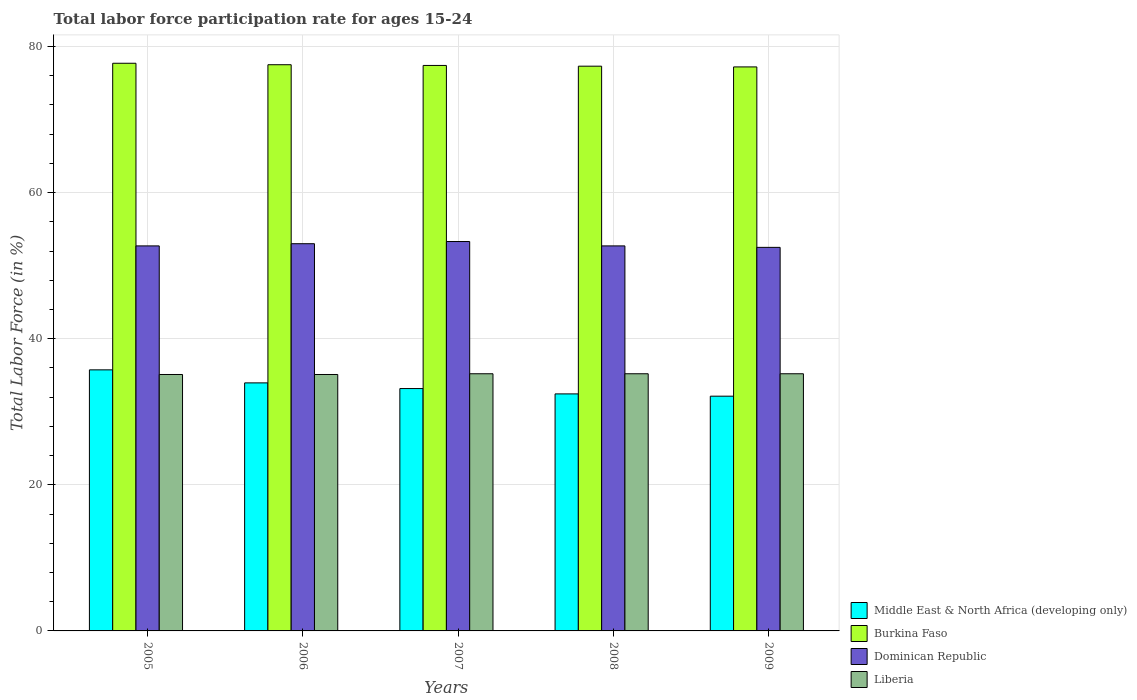How many groups of bars are there?
Offer a terse response. 5. Are the number of bars on each tick of the X-axis equal?
Provide a succinct answer. Yes. In how many cases, is the number of bars for a given year not equal to the number of legend labels?
Offer a very short reply. 0. What is the labor force participation rate in Middle East & North Africa (developing only) in 2007?
Provide a succinct answer. 33.18. Across all years, what is the maximum labor force participation rate in Middle East & North Africa (developing only)?
Your answer should be compact. 35.73. Across all years, what is the minimum labor force participation rate in Middle East & North Africa (developing only)?
Provide a short and direct response. 32.13. What is the total labor force participation rate in Middle East & North Africa (developing only) in the graph?
Offer a very short reply. 167.43. What is the difference between the labor force participation rate in Dominican Republic in 2005 and that in 2007?
Give a very brief answer. -0.6. What is the difference between the labor force participation rate in Middle East & North Africa (developing only) in 2008 and the labor force participation rate in Dominican Republic in 2009?
Offer a terse response. -20.06. What is the average labor force participation rate in Middle East & North Africa (developing only) per year?
Your answer should be compact. 33.49. In the year 2009, what is the difference between the labor force participation rate in Liberia and labor force participation rate in Burkina Faso?
Give a very brief answer. -42. What is the ratio of the labor force participation rate in Dominican Republic in 2006 to that in 2009?
Offer a terse response. 1.01. What is the difference between the highest and the second highest labor force participation rate in Burkina Faso?
Provide a succinct answer. 0.2. What is the difference between the highest and the lowest labor force participation rate in Middle East & North Africa (developing only)?
Your answer should be very brief. 3.6. In how many years, is the labor force participation rate in Burkina Faso greater than the average labor force participation rate in Burkina Faso taken over all years?
Keep it short and to the point. 2. Is the sum of the labor force participation rate in Burkina Faso in 2006 and 2007 greater than the maximum labor force participation rate in Liberia across all years?
Make the answer very short. Yes. Is it the case that in every year, the sum of the labor force participation rate in Dominican Republic and labor force participation rate in Middle East & North Africa (developing only) is greater than the sum of labor force participation rate in Burkina Faso and labor force participation rate in Liberia?
Make the answer very short. No. What does the 4th bar from the left in 2009 represents?
Ensure brevity in your answer.  Liberia. What does the 3rd bar from the right in 2007 represents?
Keep it short and to the point. Burkina Faso. Is it the case that in every year, the sum of the labor force participation rate in Dominican Republic and labor force participation rate in Liberia is greater than the labor force participation rate in Burkina Faso?
Offer a very short reply. Yes. How many bars are there?
Your response must be concise. 20. Are all the bars in the graph horizontal?
Offer a terse response. No. How many years are there in the graph?
Your answer should be very brief. 5. Does the graph contain any zero values?
Your response must be concise. No. How many legend labels are there?
Give a very brief answer. 4. What is the title of the graph?
Ensure brevity in your answer.  Total labor force participation rate for ages 15-24. Does "Gambia, The" appear as one of the legend labels in the graph?
Ensure brevity in your answer.  No. What is the label or title of the X-axis?
Provide a short and direct response. Years. What is the Total Labor Force (in %) of Middle East & North Africa (developing only) in 2005?
Offer a very short reply. 35.73. What is the Total Labor Force (in %) of Burkina Faso in 2005?
Offer a very short reply. 77.7. What is the Total Labor Force (in %) of Dominican Republic in 2005?
Offer a very short reply. 52.7. What is the Total Labor Force (in %) of Liberia in 2005?
Provide a short and direct response. 35.1. What is the Total Labor Force (in %) in Middle East & North Africa (developing only) in 2006?
Make the answer very short. 33.95. What is the Total Labor Force (in %) of Burkina Faso in 2006?
Provide a succinct answer. 77.5. What is the Total Labor Force (in %) in Liberia in 2006?
Keep it short and to the point. 35.1. What is the Total Labor Force (in %) of Middle East & North Africa (developing only) in 2007?
Ensure brevity in your answer.  33.18. What is the Total Labor Force (in %) of Burkina Faso in 2007?
Make the answer very short. 77.4. What is the Total Labor Force (in %) of Dominican Republic in 2007?
Give a very brief answer. 53.3. What is the Total Labor Force (in %) in Liberia in 2007?
Give a very brief answer. 35.2. What is the Total Labor Force (in %) in Middle East & North Africa (developing only) in 2008?
Give a very brief answer. 32.44. What is the Total Labor Force (in %) in Burkina Faso in 2008?
Provide a succinct answer. 77.3. What is the Total Labor Force (in %) of Dominican Republic in 2008?
Provide a succinct answer. 52.7. What is the Total Labor Force (in %) in Liberia in 2008?
Provide a short and direct response. 35.2. What is the Total Labor Force (in %) of Middle East & North Africa (developing only) in 2009?
Provide a succinct answer. 32.13. What is the Total Labor Force (in %) of Burkina Faso in 2009?
Keep it short and to the point. 77.2. What is the Total Labor Force (in %) in Dominican Republic in 2009?
Your answer should be compact. 52.5. What is the Total Labor Force (in %) of Liberia in 2009?
Provide a short and direct response. 35.2. Across all years, what is the maximum Total Labor Force (in %) of Middle East & North Africa (developing only)?
Ensure brevity in your answer.  35.73. Across all years, what is the maximum Total Labor Force (in %) in Burkina Faso?
Keep it short and to the point. 77.7. Across all years, what is the maximum Total Labor Force (in %) in Dominican Republic?
Offer a very short reply. 53.3. Across all years, what is the maximum Total Labor Force (in %) of Liberia?
Give a very brief answer. 35.2. Across all years, what is the minimum Total Labor Force (in %) in Middle East & North Africa (developing only)?
Ensure brevity in your answer.  32.13. Across all years, what is the minimum Total Labor Force (in %) of Burkina Faso?
Offer a terse response. 77.2. Across all years, what is the minimum Total Labor Force (in %) in Dominican Republic?
Your answer should be compact. 52.5. Across all years, what is the minimum Total Labor Force (in %) in Liberia?
Make the answer very short. 35.1. What is the total Total Labor Force (in %) of Middle East & North Africa (developing only) in the graph?
Keep it short and to the point. 167.43. What is the total Total Labor Force (in %) in Burkina Faso in the graph?
Your response must be concise. 387.1. What is the total Total Labor Force (in %) of Dominican Republic in the graph?
Your response must be concise. 264.2. What is the total Total Labor Force (in %) in Liberia in the graph?
Offer a very short reply. 175.8. What is the difference between the Total Labor Force (in %) of Middle East & North Africa (developing only) in 2005 and that in 2006?
Your answer should be very brief. 1.78. What is the difference between the Total Labor Force (in %) in Dominican Republic in 2005 and that in 2006?
Provide a succinct answer. -0.3. What is the difference between the Total Labor Force (in %) of Middle East & North Africa (developing only) in 2005 and that in 2007?
Keep it short and to the point. 2.56. What is the difference between the Total Labor Force (in %) of Middle East & North Africa (developing only) in 2005 and that in 2008?
Your answer should be very brief. 3.29. What is the difference between the Total Labor Force (in %) in Dominican Republic in 2005 and that in 2008?
Your response must be concise. 0. What is the difference between the Total Labor Force (in %) of Liberia in 2005 and that in 2008?
Your answer should be compact. -0.1. What is the difference between the Total Labor Force (in %) of Middle East & North Africa (developing only) in 2005 and that in 2009?
Make the answer very short. 3.6. What is the difference between the Total Labor Force (in %) in Middle East & North Africa (developing only) in 2006 and that in 2007?
Give a very brief answer. 0.78. What is the difference between the Total Labor Force (in %) in Burkina Faso in 2006 and that in 2007?
Your response must be concise. 0.1. What is the difference between the Total Labor Force (in %) of Middle East & North Africa (developing only) in 2006 and that in 2008?
Make the answer very short. 1.51. What is the difference between the Total Labor Force (in %) in Burkina Faso in 2006 and that in 2008?
Provide a succinct answer. 0.2. What is the difference between the Total Labor Force (in %) in Dominican Republic in 2006 and that in 2008?
Provide a succinct answer. 0.3. What is the difference between the Total Labor Force (in %) of Liberia in 2006 and that in 2008?
Ensure brevity in your answer.  -0.1. What is the difference between the Total Labor Force (in %) in Middle East & North Africa (developing only) in 2006 and that in 2009?
Give a very brief answer. 1.82. What is the difference between the Total Labor Force (in %) in Burkina Faso in 2006 and that in 2009?
Provide a short and direct response. 0.3. What is the difference between the Total Labor Force (in %) of Dominican Republic in 2006 and that in 2009?
Make the answer very short. 0.5. What is the difference between the Total Labor Force (in %) of Middle East & North Africa (developing only) in 2007 and that in 2008?
Ensure brevity in your answer.  0.73. What is the difference between the Total Labor Force (in %) of Dominican Republic in 2007 and that in 2008?
Provide a succinct answer. 0.6. What is the difference between the Total Labor Force (in %) in Middle East & North Africa (developing only) in 2007 and that in 2009?
Offer a very short reply. 1.04. What is the difference between the Total Labor Force (in %) of Burkina Faso in 2007 and that in 2009?
Give a very brief answer. 0.2. What is the difference between the Total Labor Force (in %) in Dominican Republic in 2007 and that in 2009?
Give a very brief answer. 0.8. What is the difference between the Total Labor Force (in %) in Liberia in 2007 and that in 2009?
Provide a short and direct response. 0. What is the difference between the Total Labor Force (in %) of Middle East & North Africa (developing only) in 2008 and that in 2009?
Offer a very short reply. 0.31. What is the difference between the Total Labor Force (in %) of Burkina Faso in 2008 and that in 2009?
Give a very brief answer. 0.1. What is the difference between the Total Labor Force (in %) in Dominican Republic in 2008 and that in 2009?
Provide a short and direct response. 0.2. What is the difference between the Total Labor Force (in %) of Middle East & North Africa (developing only) in 2005 and the Total Labor Force (in %) of Burkina Faso in 2006?
Your answer should be compact. -41.77. What is the difference between the Total Labor Force (in %) in Middle East & North Africa (developing only) in 2005 and the Total Labor Force (in %) in Dominican Republic in 2006?
Your response must be concise. -17.27. What is the difference between the Total Labor Force (in %) in Middle East & North Africa (developing only) in 2005 and the Total Labor Force (in %) in Liberia in 2006?
Offer a terse response. 0.63. What is the difference between the Total Labor Force (in %) of Burkina Faso in 2005 and the Total Labor Force (in %) of Dominican Republic in 2006?
Provide a succinct answer. 24.7. What is the difference between the Total Labor Force (in %) of Burkina Faso in 2005 and the Total Labor Force (in %) of Liberia in 2006?
Your response must be concise. 42.6. What is the difference between the Total Labor Force (in %) of Dominican Republic in 2005 and the Total Labor Force (in %) of Liberia in 2006?
Your response must be concise. 17.6. What is the difference between the Total Labor Force (in %) in Middle East & North Africa (developing only) in 2005 and the Total Labor Force (in %) in Burkina Faso in 2007?
Your answer should be very brief. -41.67. What is the difference between the Total Labor Force (in %) in Middle East & North Africa (developing only) in 2005 and the Total Labor Force (in %) in Dominican Republic in 2007?
Provide a short and direct response. -17.57. What is the difference between the Total Labor Force (in %) of Middle East & North Africa (developing only) in 2005 and the Total Labor Force (in %) of Liberia in 2007?
Offer a terse response. 0.53. What is the difference between the Total Labor Force (in %) of Burkina Faso in 2005 and the Total Labor Force (in %) of Dominican Republic in 2007?
Your answer should be very brief. 24.4. What is the difference between the Total Labor Force (in %) in Burkina Faso in 2005 and the Total Labor Force (in %) in Liberia in 2007?
Provide a short and direct response. 42.5. What is the difference between the Total Labor Force (in %) in Middle East & North Africa (developing only) in 2005 and the Total Labor Force (in %) in Burkina Faso in 2008?
Give a very brief answer. -41.57. What is the difference between the Total Labor Force (in %) of Middle East & North Africa (developing only) in 2005 and the Total Labor Force (in %) of Dominican Republic in 2008?
Provide a succinct answer. -16.97. What is the difference between the Total Labor Force (in %) of Middle East & North Africa (developing only) in 2005 and the Total Labor Force (in %) of Liberia in 2008?
Provide a succinct answer. 0.53. What is the difference between the Total Labor Force (in %) in Burkina Faso in 2005 and the Total Labor Force (in %) in Dominican Republic in 2008?
Provide a short and direct response. 25. What is the difference between the Total Labor Force (in %) in Burkina Faso in 2005 and the Total Labor Force (in %) in Liberia in 2008?
Provide a short and direct response. 42.5. What is the difference between the Total Labor Force (in %) in Middle East & North Africa (developing only) in 2005 and the Total Labor Force (in %) in Burkina Faso in 2009?
Ensure brevity in your answer.  -41.47. What is the difference between the Total Labor Force (in %) in Middle East & North Africa (developing only) in 2005 and the Total Labor Force (in %) in Dominican Republic in 2009?
Provide a succinct answer. -16.77. What is the difference between the Total Labor Force (in %) of Middle East & North Africa (developing only) in 2005 and the Total Labor Force (in %) of Liberia in 2009?
Offer a terse response. 0.53. What is the difference between the Total Labor Force (in %) of Burkina Faso in 2005 and the Total Labor Force (in %) of Dominican Republic in 2009?
Provide a short and direct response. 25.2. What is the difference between the Total Labor Force (in %) of Burkina Faso in 2005 and the Total Labor Force (in %) of Liberia in 2009?
Provide a short and direct response. 42.5. What is the difference between the Total Labor Force (in %) in Dominican Republic in 2005 and the Total Labor Force (in %) in Liberia in 2009?
Your answer should be very brief. 17.5. What is the difference between the Total Labor Force (in %) of Middle East & North Africa (developing only) in 2006 and the Total Labor Force (in %) of Burkina Faso in 2007?
Provide a succinct answer. -43.45. What is the difference between the Total Labor Force (in %) of Middle East & North Africa (developing only) in 2006 and the Total Labor Force (in %) of Dominican Republic in 2007?
Offer a very short reply. -19.35. What is the difference between the Total Labor Force (in %) of Middle East & North Africa (developing only) in 2006 and the Total Labor Force (in %) of Liberia in 2007?
Make the answer very short. -1.25. What is the difference between the Total Labor Force (in %) of Burkina Faso in 2006 and the Total Labor Force (in %) of Dominican Republic in 2007?
Your answer should be compact. 24.2. What is the difference between the Total Labor Force (in %) in Burkina Faso in 2006 and the Total Labor Force (in %) in Liberia in 2007?
Provide a succinct answer. 42.3. What is the difference between the Total Labor Force (in %) of Middle East & North Africa (developing only) in 2006 and the Total Labor Force (in %) of Burkina Faso in 2008?
Give a very brief answer. -43.35. What is the difference between the Total Labor Force (in %) of Middle East & North Africa (developing only) in 2006 and the Total Labor Force (in %) of Dominican Republic in 2008?
Your answer should be compact. -18.75. What is the difference between the Total Labor Force (in %) of Middle East & North Africa (developing only) in 2006 and the Total Labor Force (in %) of Liberia in 2008?
Provide a succinct answer. -1.25. What is the difference between the Total Labor Force (in %) in Burkina Faso in 2006 and the Total Labor Force (in %) in Dominican Republic in 2008?
Give a very brief answer. 24.8. What is the difference between the Total Labor Force (in %) in Burkina Faso in 2006 and the Total Labor Force (in %) in Liberia in 2008?
Your answer should be compact. 42.3. What is the difference between the Total Labor Force (in %) of Dominican Republic in 2006 and the Total Labor Force (in %) of Liberia in 2008?
Offer a terse response. 17.8. What is the difference between the Total Labor Force (in %) of Middle East & North Africa (developing only) in 2006 and the Total Labor Force (in %) of Burkina Faso in 2009?
Your answer should be very brief. -43.25. What is the difference between the Total Labor Force (in %) in Middle East & North Africa (developing only) in 2006 and the Total Labor Force (in %) in Dominican Republic in 2009?
Ensure brevity in your answer.  -18.55. What is the difference between the Total Labor Force (in %) in Middle East & North Africa (developing only) in 2006 and the Total Labor Force (in %) in Liberia in 2009?
Your answer should be very brief. -1.25. What is the difference between the Total Labor Force (in %) in Burkina Faso in 2006 and the Total Labor Force (in %) in Liberia in 2009?
Make the answer very short. 42.3. What is the difference between the Total Labor Force (in %) in Middle East & North Africa (developing only) in 2007 and the Total Labor Force (in %) in Burkina Faso in 2008?
Your response must be concise. -44.12. What is the difference between the Total Labor Force (in %) of Middle East & North Africa (developing only) in 2007 and the Total Labor Force (in %) of Dominican Republic in 2008?
Keep it short and to the point. -19.52. What is the difference between the Total Labor Force (in %) of Middle East & North Africa (developing only) in 2007 and the Total Labor Force (in %) of Liberia in 2008?
Offer a very short reply. -2.02. What is the difference between the Total Labor Force (in %) in Burkina Faso in 2007 and the Total Labor Force (in %) in Dominican Republic in 2008?
Give a very brief answer. 24.7. What is the difference between the Total Labor Force (in %) of Burkina Faso in 2007 and the Total Labor Force (in %) of Liberia in 2008?
Make the answer very short. 42.2. What is the difference between the Total Labor Force (in %) of Middle East & North Africa (developing only) in 2007 and the Total Labor Force (in %) of Burkina Faso in 2009?
Ensure brevity in your answer.  -44.02. What is the difference between the Total Labor Force (in %) of Middle East & North Africa (developing only) in 2007 and the Total Labor Force (in %) of Dominican Republic in 2009?
Your response must be concise. -19.32. What is the difference between the Total Labor Force (in %) of Middle East & North Africa (developing only) in 2007 and the Total Labor Force (in %) of Liberia in 2009?
Provide a succinct answer. -2.02. What is the difference between the Total Labor Force (in %) of Burkina Faso in 2007 and the Total Labor Force (in %) of Dominican Republic in 2009?
Provide a succinct answer. 24.9. What is the difference between the Total Labor Force (in %) in Burkina Faso in 2007 and the Total Labor Force (in %) in Liberia in 2009?
Your answer should be compact. 42.2. What is the difference between the Total Labor Force (in %) of Dominican Republic in 2007 and the Total Labor Force (in %) of Liberia in 2009?
Offer a very short reply. 18.1. What is the difference between the Total Labor Force (in %) of Middle East & North Africa (developing only) in 2008 and the Total Labor Force (in %) of Burkina Faso in 2009?
Your answer should be very brief. -44.76. What is the difference between the Total Labor Force (in %) in Middle East & North Africa (developing only) in 2008 and the Total Labor Force (in %) in Dominican Republic in 2009?
Your answer should be compact. -20.06. What is the difference between the Total Labor Force (in %) of Middle East & North Africa (developing only) in 2008 and the Total Labor Force (in %) of Liberia in 2009?
Keep it short and to the point. -2.76. What is the difference between the Total Labor Force (in %) in Burkina Faso in 2008 and the Total Labor Force (in %) in Dominican Republic in 2009?
Ensure brevity in your answer.  24.8. What is the difference between the Total Labor Force (in %) of Burkina Faso in 2008 and the Total Labor Force (in %) of Liberia in 2009?
Offer a very short reply. 42.1. What is the difference between the Total Labor Force (in %) of Dominican Republic in 2008 and the Total Labor Force (in %) of Liberia in 2009?
Keep it short and to the point. 17.5. What is the average Total Labor Force (in %) of Middle East & North Africa (developing only) per year?
Give a very brief answer. 33.49. What is the average Total Labor Force (in %) in Burkina Faso per year?
Provide a short and direct response. 77.42. What is the average Total Labor Force (in %) in Dominican Republic per year?
Provide a short and direct response. 52.84. What is the average Total Labor Force (in %) of Liberia per year?
Your answer should be compact. 35.16. In the year 2005, what is the difference between the Total Labor Force (in %) of Middle East & North Africa (developing only) and Total Labor Force (in %) of Burkina Faso?
Ensure brevity in your answer.  -41.97. In the year 2005, what is the difference between the Total Labor Force (in %) of Middle East & North Africa (developing only) and Total Labor Force (in %) of Dominican Republic?
Your answer should be compact. -16.97. In the year 2005, what is the difference between the Total Labor Force (in %) in Middle East & North Africa (developing only) and Total Labor Force (in %) in Liberia?
Your response must be concise. 0.63. In the year 2005, what is the difference between the Total Labor Force (in %) in Burkina Faso and Total Labor Force (in %) in Dominican Republic?
Make the answer very short. 25. In the year 2005, what is the difference between the Total Labor Force (in %) in Burkina Faso and Total Labor Force (in %) in Liberia?
Provide a succinct answer. 42.6. In the year 2006, what is the difference between the Total Labor Force (in %) of Middle East & North Africa (developing only) and Total Labor Force (in %) of Burkina Faso?
Ensure brevity in your answer.  -43.55. In the year 2006, what is the difference between the Total Labor Force (in %) in Middle East & North Africa (developing only) and Total Labor Force (in %) in Dominican Republic?
Ensure brevity in your answer.  -19.05. In the year 2006, what is the difference between the Total Labor Force (in %) of Middle East & North Africa (developing only) and Total Labor Force (in %) of Liberia?
Keep it short and to the point. -1.15. In the year 2006, what is the difference between the Total Labor Force (in %) in Burkina Faso and Total Labor Force (in %) in Liberia?
Provide a short and direct response. 42.4. In the year 2006, what is the difference between the Total Labor Force (in %) in Dominican Republic and Total Labor Force (in %) in Liberia?
Your answer should be very brief. 17.9. In the year 2007, what is the difference between the Total Labor Force (in %) in Middle East & North Africa (developing only) and Total Labor Force (in %) in Burkina Faso?
Keep it short and to the point. -44.22. In the year 2007, what is the difference between the Total Labor Force (in %) in Middle East & North Africa (developing only) and Total Labor Force (in %) in Dominican Republic?
Your answer should be very brief. -20.12. In the year 2007, what is the difference between the Total Labor Force (in %) in Middle East & North Africa (developing only) and Total Labor Force (in %) in Liberia?
Ensure brevity in your answer.  -2.02. In the year 2007, what is the difference between the Total Labor Force (in %) of Burkina Faso and Total Labor Force (in %) of Dominican Republic?
Your response must be concise. 24.1. In the year 2007, what is the difference between the Total Labor Force (in %) in Burkina Faso and Total Labor Force (in %) in Liberia?
Your response must be concise. 42.2. In the year 2007, what is the difference between the Total Labor Force (in %) of Dominican Republic and Total Labor Force (in %) of Liberia?
Offer a terse response. 18.1. In the year 2008, what is the difference between the Total Labor Force (in %) of Middle East & North Africa (developing only) and Total Labor Force (in %) of Burkina Faso?
Keep it short and to the point. -44.86. In the year 2008, what is the difference between the Total Labor Force (in %) in Middle East & North Africa (developing only) and Total Labor Force (in %) in Dominican Republic?
Offer a very short reply. -20.26. In the year 2008, what is the difference between the Total Labor Force (in %) in Middle East & North Africa (developing only) and Total Labor Force (in %) in Liberia?
Your answer should be very brief. -2.76. In the year 2008, what is the difference between the Total Labor Force (in %) in Burkina Faso and Total Labor Force (in %) in Dominican Republic?
Keep it short and to the point. 24.6. In the year 2008, what is the difference between the Total Labor Force (in %) in Burkina Faso and Total Labor Force (in %) in Liberia?
Provide a succinct answer. 42.1. In the year 2008, what is the difference between the Total Labor Force (in %) of Dominican Republic and Total Labor Force (in %) of Liberia?
Ensure brevity in your answer.  17.5. In the year 2009, what is the difference between the Total Labor Force (in %) in Middle East & North Africa (developing only) and Total Labor Force (in %) in Burkina Faso?
Provide a short and direct response. -45.07. In the year 2009, what is the difference between the Total Labor Force (in %) of Middle East & North Africa (developing only) and Total Labor Force (in %) of Dominican Republic?
Keep it short and to the point. -20.37. In the year 2009, what is the difference between the Total Labor Force (in %) in Middle East & North Africa (developing only) and Total Labor Force (in %) in Liberia?
Ensure brevity in your answer.  -3.07. In the year 2009, what is the difference between the Total Labor Force (in %) in Burkina Faso and Total Labor Force (in %) in Dominican Republic?
Your answer should be compact. 24.7. In the year 2009, what is the difference between the Total Labor Force (in %) of Dominican Republic and Total Labor Force (in %) of Liberia?
Make the answer very short. 17.3. What is the ratio of the Total Labor Force (in %) in Middle East & North Africa (developing only) in 2005 to that in 2006?
Ensure brevity in your answer.  1.05. What is the ratio of the Total Labor Force (in %) of Dominican Republic in 2005 to that in 2006?
Your response must be concise. 0.99. What is the ratio of the Total Labor Force (in %) of Middle East & North Africa (developing only) in 2005 to that in 2007?
Keep it short and to the point. 1.08. What is the ratio of the Total Labor Force (in %) in Dominican Republic in 2005 to that in 2007?
Ensure brevity in your answer.  0.99. What is the ratio of the Total Labor Force (in %) in Middle East & North Africa (developing only) in 2005 to that in 2008?
Ensure brevity in your answer.  1.1. What is the ratio of the Total Labor Force (in %) of Dominican Republic in 2005 to that in 2008?
Offer a terse response. 1. What is the ratio of the Total Labor Force (in %) of Middle East & North Africa (developing only) in 2005 to that in 2009?
Your response must be concise. 1.11. What is the ratio of the Total Labor Force (in %) of Burkina Faso in 2005 to that in 2009?
Offer a very short reply. 1.01. What is the ratio of the Total Labor Force (in %) of Dominican Republic in 2005 to that in 2009?
Provide a succinct answer. 1. What is the ratio of the Total Labor Force (in %) of Middle East & North Africa (developing only) in 2006 to that in 2007?
Provide a short and direct response. 1.02. What is the ratio of the Total Labor Force (in %) in Middle East & North Africa (developing only) in 2006 to that in 2008?
Make the answer very short. 1.05. What is the ratio of the Total Labor Force (in %) in Dominican Republic in 2006 to that in 2008?
Your response must be concise. 1.01. What is the ratio of the Total Labor Force (in %) in Middle East & North Africa (developing only) in 2006 to that in 2009?
Your response must be concise. 1.06. What is the ratio of the Total Labor Force (in %) of Burkina Faso in 2006 to that in 2009?
Provide a short and direct response. 1. What is the ratio of the Total Labor Force (in %) of Dominican Republic in 2006 to that in 2009?
Your response must be concise. 1.01. What is the ratio of the Total Labor Force (in %) in Middle East & North Africa (developing only) in 2007 to that in 2008?
Provide a short and direct response. 1.02. What is the ratio of the Total Labor Force (in %) of Dominican Republic in 2007 to that in 2008?
Give a very brief answer. 1.01. What is the ratio of the Total Labor Force (in %) of Liberia in 2007 to that in 2008?
Offer a terse response. 1. What is the ratio of the Total Labor Force (in %) of Middle East & North Africa (developing only) in 2007 to that in 2009?
Your answer should be compact. 1.03. What is the ratio of the Total Labor Force (in %) of Dominican Republic in 2007 to that in 2009?
Your answer should be compact. 1.02. What is the ratio of the Total Labor Force (in %) of Middle East & North Africa (developing only) in 2008 to that in 2009?
Your answer should be compact. 1.01. What is the difference between the highest and the second highest Total Labor Force (in %) in Middle East & North Africa (developing only)?
Provide a short and direct response. 1.78. What is the difference between the highest and the lowest Total Labor Force (in %) of Middle East & North Africa (developing only)?
Give a very brief answer. 3.6. 